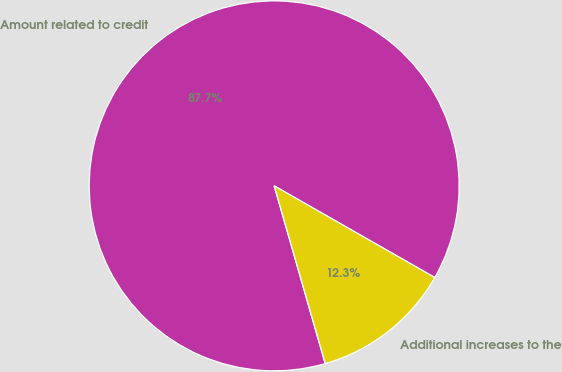Convert chart to OTSL. <chart><loc_0><loc_0><loc_500><loc_500><pie_chart><fcel>Amount related to credit<fcel>Additional increases to the<nl><fcel>87.71%<fcel>12.29%<nl></chart> 